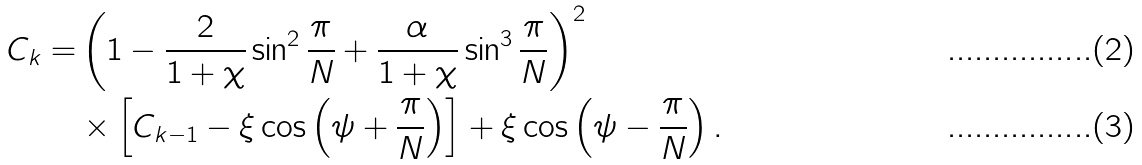Convert formula to latex. <formula><loc_0><loc_0><loc_500><loc_500>C _ { k } = & \left ( 1 - \frac { 2 } { 1 + \chi } \sin ^ { 2 } \frac { \pi } { N } + \frac { \alpha } { 1 + \chi } \sin ^ { 3 } \frac { \pi } { N } \right ) ^ { 2 } \\ & \times \left [ C _ { k - 1 } - \xi \cos \left ( \psi + \frac { \pi } { N } \right ) \right ] + \xi \cos \left ( \psi - \frac { \pi } { N } \right ) .</formula> 